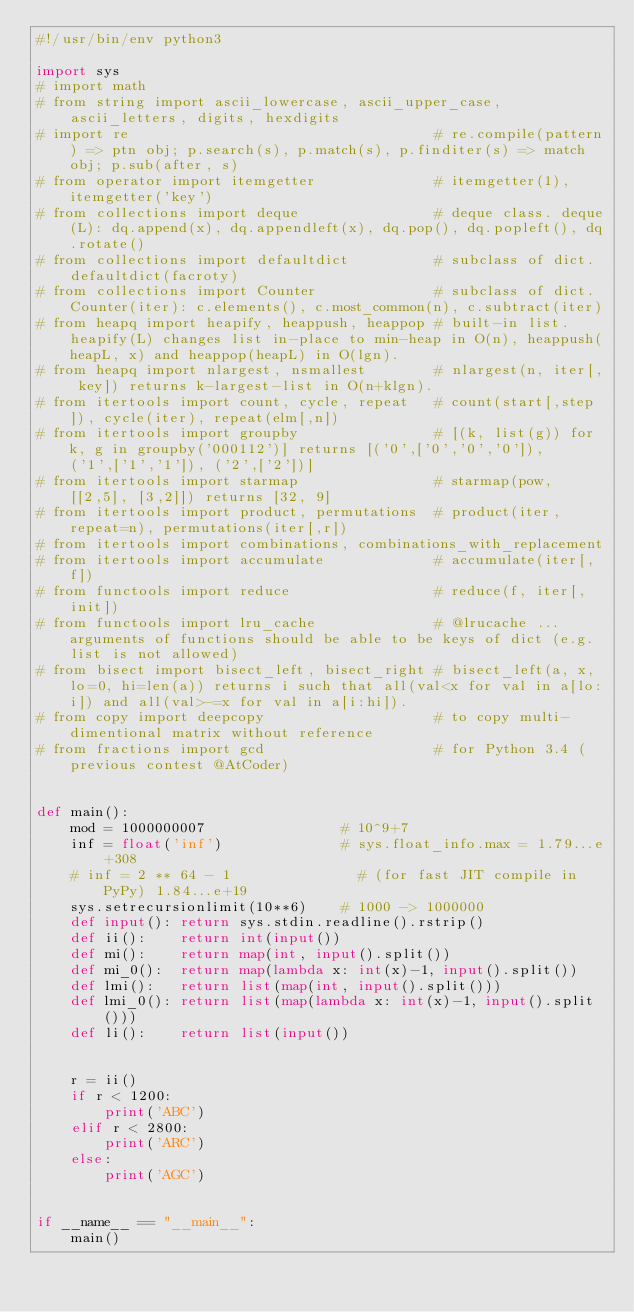Convert code to text. <code><loc_0><loc_0><loc_500><loc_500><_Python_>#!/usr/bin/env python3

import sys
# import math
# from string import ascii_lowercase, ascii_upper_case, ascii_letters, digits, hexdigits
# import re                                    # re.compile(pattern) => ptn obj; p.search(s), p.match(s), p.finditer(s) => match obj; p.sub(after, s)
# from operator import itemgetter              # itemgetter(1), itemgetter('key')
# from collections import deque                # deque class. deque(L): dq.append(x), dq.appendleft(x), dq.pop(), dq.popleft(), dq.rotate()
# from collections import defaultdict          # subclass of dict. defaultdict(facroty)
# from collections import Counter              # subclass of dict. Counter(iter): c.elements(), c.most_common(n), c.subtract(iter)
# from heapq import heapify, heappush, heappop # built-in list. heapify(L) changes list in-place to min-heap in O(n), heappush(heapL, x) and heappop(heapL) in O(lgn).
# from heapq import nlargest, nsmallest        # nlargest(n, iter[, key]) returns k-largest-list in O(n+klgn).
# from itertools import count, cycle, repeat   # count(start[,step]), cycle(iter), repeat(elm[,n])
# from itertools import groupby                # [(k, list(g)) for k, g in groupby('000112')] returns [('0',['0','0','0']), ('1',['1','1']), ('2',['2'])]
# from itertools import starmap                # starmap(pow, [[2,5], [3,2]]) returns [32, 9]
# from itertools import product, permutations  # product(iter, repeat=n), permutations(iter[,r])
# from itertools import combinations, combinations_with_replacement
# from itertools import accumulate             # accumulate(iter[, f])
# from functools import reduce                 # reduce(f, iter[, init])
# from functools import lru_cache              # @lrucache ...arguments of functions should be able to be keys of dict (e.g. list is not allowed)
# from bisect import bisect_left, bisect_right # bisect_left(a, x, lo=0, hi=len(a)) returns i such that all(val<x for val in a[lo:i]) and all(val>-=x for val in a[i:hi]).
# from copy import deepcopy                    # to copy multi-dimentional matrix without reference
# from fractions import gcd                    # for Python 3.4 (previous contest @AtCoder)


def main():
    mod = 1000000007                # 10^9+7
    inf = float('inf')              # sys.float_info.max = 1.79...e+308
    # inf = 2 ** 64 - 1               # (for fast JIT compile in PyPy) 1.84...e+19
    sys.setrecursionlimit(10**6)    # 1000 -> 1000000
    def input(): return sys.stdin.readline().rstrip()
    def ii():    return int(input())
    def mi():    return map(int, input().split())
    def mi_0():  return map(lambda x: int(x)-1, input().split())
    def lmi():   return list(map(int, input().split()))
    def lmi_0(): return list(map(lambda x: int(x)-1, input().split()))
    def li():    return list(input())
    
    
    r = ii()
    if r < 1200:
        print('ABC')
    elif r < 2800:
        print('ARC')
    else:
        print('AGC')


if __name__ == "__main__":
    main()
</code> 